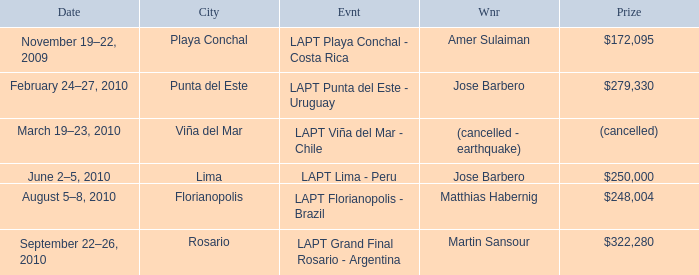What is the date of the event with a $322,280 prize? September 22–26, 2010. 